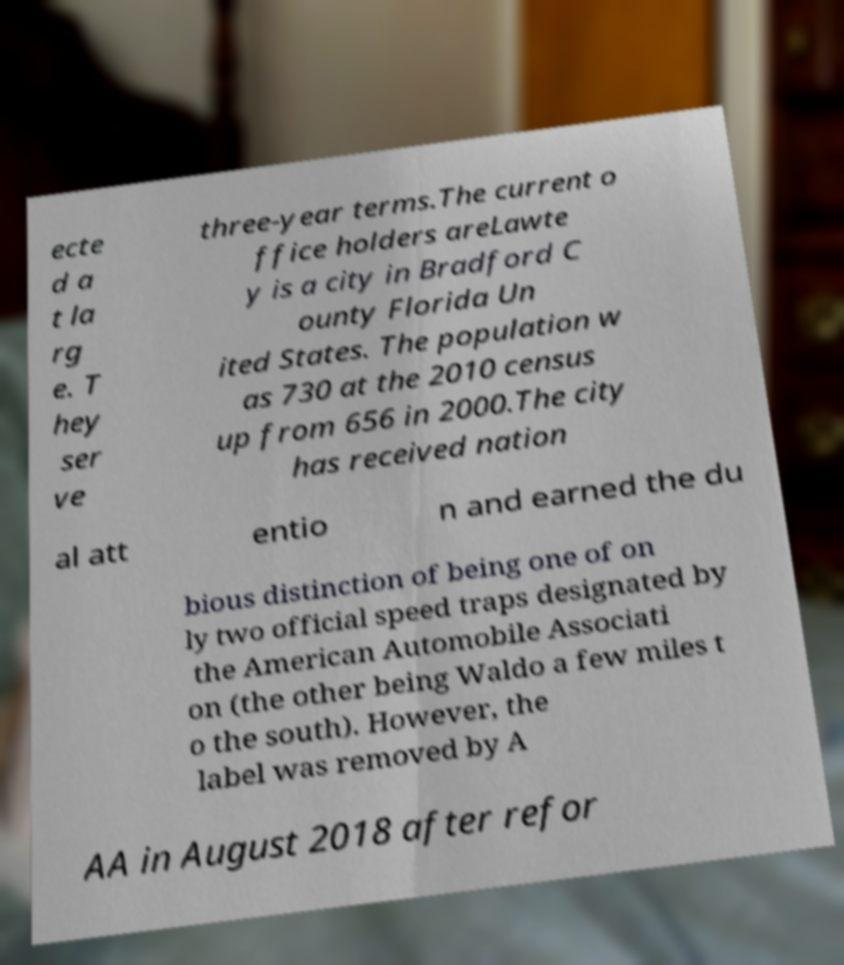I need the written content from this picture converted into text. Can you do that? ecte d a t la rg e. T hey ser ve three-year terms.The current o ffice holders areLawte y is a city in Bradford C ounty Florida Un ited States. The population w as 730 at the 2010 census up from 656 in 2000.The city has received nation al att entio n and earned the du bious distinction of being one of on ly two official speed traps designated by the American Automobile Associati on (the other being Waldo a few miles t o the south). However, the label was removed by A AA in August 2018 after refor 